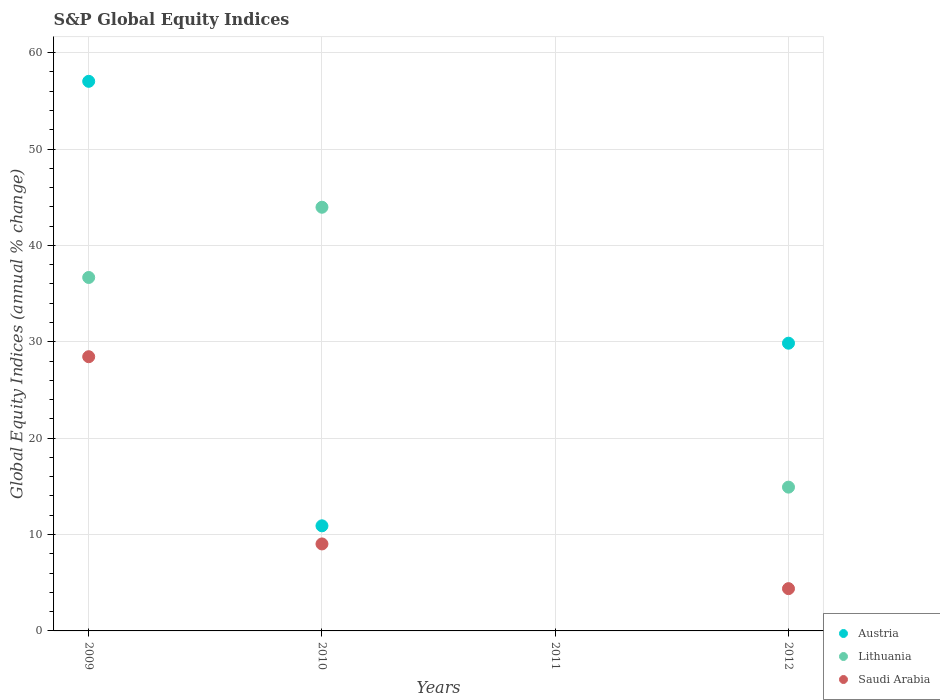How many different coloured dotlines are there?
Keep it short and to the point. 3. Is the number of dotlines equal to the number of legend labels?
Provide a short and direct response. No. What is the global equity indices in Austria in 2009?
Provide a short and direct response. 57.02. Across all years, what is the maximum global equity indices in Saudi Arabia?
Provide a succinct answer. 28.45. Across all years, what is the minimum global equity indices in Saudi Arabia?
Give a very brief answer. 0. What is the total global equity indices in Saudi Arabia in the graph?
Offer a terse response. 41.86. What is the difference between the global equity indices in Austria in 2009 and that in 2012?
Offer a terse response. 27.17. What is the difference between the global equity indices in Austria in 2012 and the global equity indices in Lithuania in 2009?
Offer a very short reply. -6.82. What is the average global equity indices in Lithuania per year?
Give a very brief answer. 23.89. In the year 2009, what is the difference between the global equity indices in Austria and global equity indices in Saudi Arabia?
Provide a succinct answer. 28.57. What is the ratio of the global equity indices in Lithuania in 2009 to that in 2012?
Keep it short and to the point. 2.46. Is the global equity indices in Austria in 2010 less than that in 2012?
Your answer should be compact. Yes. Is the difference between the global equity indices in Austria in 2010 and 2012 greater than the difference between the global equity indices in Saudi Arabia in 2010 and 2012?
Your answer should be compact. No. What is the difference between the highest and the second highest global equity indices in Lithuania?
Keep it short and to the point. 7.29. What is the difference between the highest and the lowest global equity indices in Saudi Arabia?
Offer a terse response. 28.45. In how many years, is the global equity indices in Lithuania greater than the average global equity indices in Lithuania taken over all years?
Keep it short and to the point. 2. Is it the case that in every year, the sum of the global equity indices in Lithuania and global equity indices in Saudi Arabia  is greater than the global equity indices in Austria?
Your answer should be compact. No. Is the global equity indices in Saudi Arabia strictly greater than the global equity indices in Austria over the years?
Make the answer very short. No. How many dotlines are there?
Give a very brief answer. 3. What is the difference between two consecutive major ticks on the Y-axis?
Keep it short and to the point. 10. Does the graph contain any zero values?
Your answer should be compact. Yes. Where does the legend appear in the graph?
Ensure brevity in your answer.  Bottom right. How are the legend labels stacked?
Provide a short and direct response. Vertical. What is the title of the graph?
Make the answer very short. S&P Global Equity Indices. Does "Denmark" appear as one of the legend labels in the graph?
Provide a succinct answer. No. What is the label or title of the X-axis?
Offer a terse response. Years. What is the label or title of the Y-axis?
Offer a very short reply. Global Equity Indices (annual % change). What is the Global Equity Indices (annual % change) of Austria in 2009?
Keep it short and to the point. 57.02. What is the Global Equity Indices (annual % change) of Lithuania in 2009?
Your answer should be compact. 36.67. What is the Global Equity Indices (annual % change) of Saudi Arabia in 2009?
Offer a terse response. 28.45. What is the Global Equity Indices (annual % change) in Austria in 2010?
Offer a very short reply. 10.9. What is the Global Equity Indices (annual % change) of Lithuania in 2010?
Offer a terse response. 43.96. What is the Global Equity Indices (annual % change) in Saudi Arabia in 2010?
Give a very brief answer. 9.02. What is the Global Equity Indices (annual % change) of Austria in 2011?
Keep it short and to the point. 0. What is the Global Equity Indices (annual % change) in Lithuania in 2011?
Your answer should be very brief. 0. What is the Global Equity Indices (annual % change) in Saudi Arabia in 2011?
Offer a terse response. 0. What is the Global Equity Indices (annual % change) of Austria in 2012?
Give a very brief answer. 29.85. What is the Global Equity Indices (annual % change) of Lithuania in 2012?
Provide a succinct answer. 14.92. What is the Global Equity Indices (annual % change) of Saudi Arabia in 2012?
Your answer should be compact. 4.39. Across all years, what is the maximum Global Equity Indices (annual % change) in Austria?
Provide a succinct answer. 57.02. Across all years, what is the maximum Global Equity Indices (annual % change) of Lithuania?
Provide a succinct answer. 43.96. Across all years, what is the maximum Global Equity Indices (annual % change) of Saudi Arabia?
Provide a short and direct response. 28.45. What is the total Global Equity Indices (annual % change) in Austria in the graph?
Offer a very short reply. 97.78. What is the total Global Equity Indices (annual % change) in Lithuania in the graph?
Provide a short and direct response. 95.54. What is the total Global Equity Indices (annual % change) in Saudi Arabia in the graph?
Give a very brief answer. 41.86. What is the difference between the Global Equity Indices (annual % change) in Austria in 2009 and that in 2010?
Provide a short and direct response. 46.12. What is the difference between the Global Equity Indices (annual % change) in Lithuania in 2009 and that in 2010?
Keep it short and to the point. -7.29. What is the difference between the Global Equity Indices (annual % change) in Saudi Arabia in 2009 and that in 2010?
Make the answer very short. 19.43. What is the difference between the Global Equity Indices (annual % change) of Austria in 2009 and that in 2012?
Offer a terse response. 27.17. What is the difference between the Global Equity Indices (annual % change) in Lithuania in 2009 and that in 2012?
Give a very brief answer. 21.75. What is the difference between the Global Equity Indices (annual % change) of Saudi Arabia in 2009 and that in 2012?
Ensure brevity in your answer.  24.06. What is the difference between the Global Equity Indices (annual % change) in Austria in 2010 and that in 2012?
Keep it short and to the point. -18.95. What is the difference between the Global Equity Indices (annual % change) in Lithuania in 2010 and that in 2012?
Provide a short and direct response. 29.04. What is the difference between the Global Equity Indices (annual % change) of Saudi Arabia in 2010 and that in 2012?
Keep it short and to the point. 4.64. What is the difference between the Global Equity Indices (annual % change) in Austria in 2009 and the Global Equity Indices (annual % change) in Lithuania in 2010?
Make the answer very short. 13.06. What is the difference between the Global Equity Indices (annual % change) of Austria in 2009 and the Global Equity Indices (annual % change) of Saudi Arabia in 2010?
Your answer should be very brief. 48. What is the difference between the Global Equity Indices (annual % change) of Lithuania in 2009 and the Global Equity Indices (annual % change) of Saudi Arabia in 2010?
Offer a very short reply. 27.65. What is the difference between the Global Equity Indices (annual % change) of Austria in 2009 and the Global Equity Indices (annual % change) of Lithuania in 2012?
Provide a succinct answer. 42.1. What is the difference between the Global Equity Indices (annual % change) of Austria in 2009 and the Global Equity Indices (annual % change) of Saudi Arabia in 2012?
Provide a succinct answer. 52.64. What is the difference between the Global Equity Indices (annual % change) in Lithuania in 2009 and the Global Equity Indices (annual % change) in Saudi Arabia in 2012?
Keep it short and to the point. 32.28. What is the difference between the Global Equity Indices (annual % change) of Austria in 2010 and the Global Equity Indices (annual % change) of Lithuania in 2012?
Offer a terse response. -4.01. What is the difference between the Global Equity Indices (annual % change) in Austria in 2010 and the Global Equity Indices (annual % change) in Saudi Arabia in 2012?
Offer a very short reply. 6.52. What is the difference between the Global Equity Indices (annual % change) in Lithuania in 2010 and the Global Equity Indices (annual % change) in Saudi Arabia in 2012?
Offer a very short reply. 39.57. What is the average Global Equity Indices (annual % change) in Austria per year?
Your answer should be very brief. 24.44. What is the average Global Equity Indices (annual % change) in Lithuania per year?
Make the answer very short. 23.89. What is the average Global Equity Indices (annual % change) in Saudi Arabia per year?
Give a very brief answer. 10.47. In the year 2009, what is the difference between the Global Equity Indices (annual % change) in Austria and Global Equity Indices (annual % change) in Lithuania?
Give a very brief answer. 20.35. In the year 2009, what is the difference between the Global Equity Indices (annual % change) in Austria and Global Equity Indices (annual % change) in Saudi Arabia?
Offer a very short reply. 28.57. In the year 2009, what is the difference between the Global Equity Indices (annual % change) in Lithuania and Global Equity Indices (annual % change) in Saudi Arabia?
Give a very brief answer. 8.22. In the year 2010, what is the difference between the Global Equity Indices (annual % change) of Austria and Global Equity Indices (annual % change) of Lithuania?
Offer a terse response. -33.05. In the year 2010, what is the difference between the Global Equity Indices (annual % change) in Austria and Global Equity Indices (annual % change) in Saudi Arabia?
Make the answer very short. 1.88. In the year 2010, what is the difference between the Global Equity Indices (annual % change) in Lithuania and Global Equity Indices (annual % change) in Saudi Arabia?
Offer a terse response. 34.93. In the year 2012, what is the difference between the Global Equity Indices (annual % change) of Austria and Global Equity Indices (annual % change) of Lithuania?
Provide a succinct answer. 14.93. In the year 2012, what is the difference between the Global Equity Indices (annual % change) of Austria and Global Equity Indices (annual % change) of Saudi Arabia?
Make the answer very short. 25.47. In the year 2012, what is the difference between the Global Equity Indices (annual % change) of Lithuania and Global Equity Indices (annual % change) of Saudi Arabia?
Offer a very short reply. 10.53. What is the ratio of the Global Equity Indices (annual % change) in Austria in 2009 to that in 2010?
Your answer should be compact. 5.23. What is the ratio of the Global Equity Indices (annual % change) of Lithuania in 2009 to that in 2010?
Provide a short and direct response. 0.83. What is the ratio of the Global Equity Indices (annual % change) in Saudi Arabia in 2009 to that in 2010?
Offer a terse response. 3.15. What is the ratio of the Global Equity Indices (annual % change) of Austria in 2009 to that in 2012?
Give a very brief answer. 1.91. What is the ratio of the Global Equity Indices (annual % change) in Lithuania in 2009 to that in 2012?
Give a very brief answer. 2.46. What is the ratio of the Global Equity Indices (annual % change) of Saudi Arabia in 2009 to that in 2012?
Your response must be concise. 6.49. What is the ratio of the Global Equity Indices (annual % change) of Austria in 2010 to that in 2012?
Provide a succinct answer. 0.37. What is the ratio of the Global Equity Indices (annual % change) of Lithuania in 2010 to that in 2012?
Your answer should be compact. 2.95. What is the ratio of the Global Equity Indices (annual % change) in Saudi Arabia in 2010 to that in 2012?
Your answer should be compact. 2.06. What is the difference between the highest and the second highest Global Equity Indices (annual % change) of Austria?
Make the answer very short. 27.17. What is the difference between the highest and the second highest Global Equity Indices (annual % change) in Lithuania?
Your answer should be compact. 7.29. What is the difference between the highest and the second highest Global Equity Indices (annual % change) in Saudi Arabia?
Your answer should be very brief. 19.43. What is the difference between the highest and the lowest Global Equity Indices (annual % change) in Austria?
Offer a very short reply. 57.02. What is the difference between the highest and the lowest Global Equity Indices (annual % change) in Lithuania?
Offer a terse response. 43.96. What is the difference between the highest and the lowest Global Equity Indices (annual % change) of Saudi Arabia?
Your response must be concise. 28.45. 